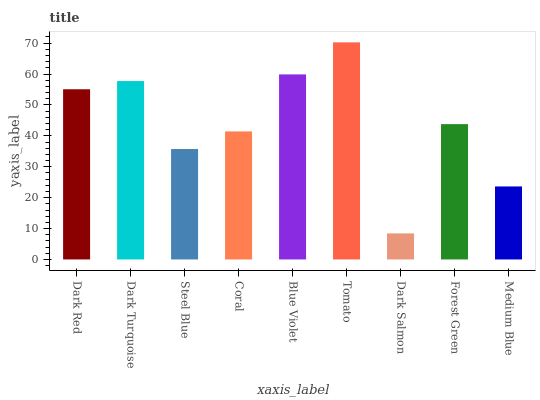Is Dark Salmon the minimum?
Answer yes or no. Yes. Is Tomato the maximum?
Answer yes or no. Yes. Is Dark Turquoise the minimum?
Answer yes or no. No. Is Dark Turquoise the maximum?
Answer yes or no. No. Is Dark Turquoise greater than Dark Red?
Answer yes or no. Yes. Is Dark Red less than Dark Turquoise?
Answer yes or no. Yes. Is Dark Red greater than Dark Turquoise?
Answer yes or no. No. Is Dark Turquoise less than Dark Red?
Answer yes or no. No. Is Forest Green the high median?
Answer yes or no. Yes. Is Forest Green the low median?
Answer yes or no. Yes. Is Tomato the high median?
Answer yes or no. No. Is Tomato the low median?
Answer yes or no. No. 